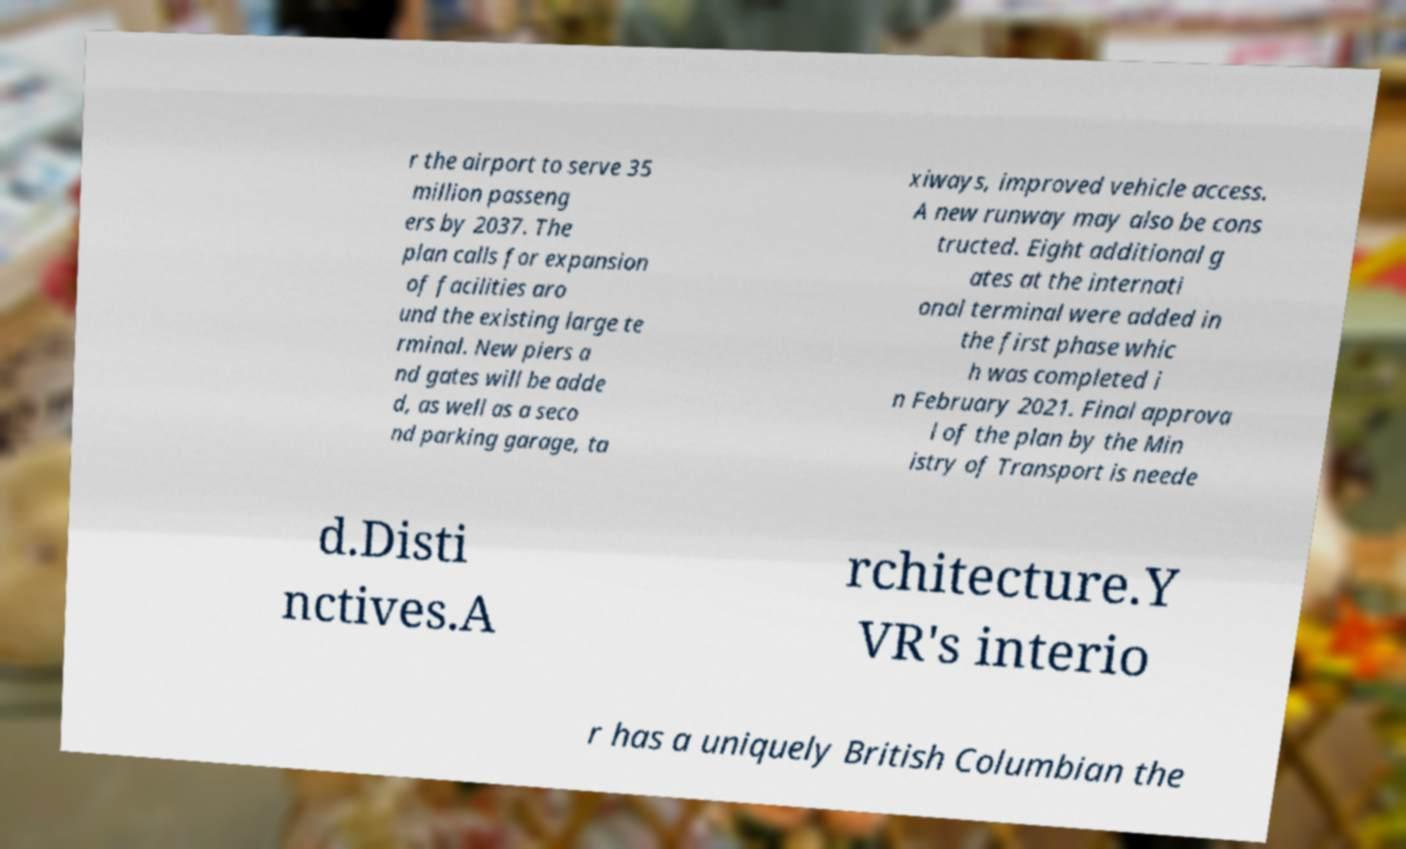What messages or text are displayed in this image? I need them in a readable, typed format. r the airport to serve 35 million passeng ers by 2037. The plan calls for expansion of facilities aro und the existing large te rminal. New piers a nd gates will be adde d, as well as a seco nd parking garage, ta xiways, improved vehicle access. A new runway may also be cons tructed. Eight additional g ates at the internati onal terminal were added in the first phase whic h was completed i n February 2021. Final approva l of the plan by the Min istry of Transport is neede d.Disti nctives.A rchitecture.Y VR's interio r has a uniquely British Columbian the 